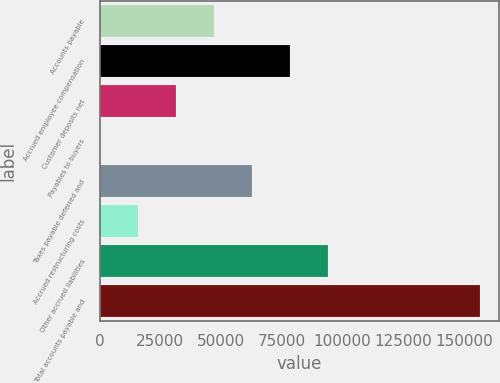Convert chart to OTSL. <chart><loc_0><loc_0><loc_500><loc_500><bar_chart><fcel>Accounts payable<fcel>Accrued employee compensation<fcel>Customer deposits net<fcel>Payables to buyers<fcel>Taxes payable deferred and<fcel>Accrued restructuring costs<fcel>Other accrued liabilities<fcel>Total accounts payable and<nl><fcel>47076.5<fcel>78307.5<fcel>31461<fcel>230<fcel>62692<fcel>15845.5<fcel>93923<fcel>156385<nl></chart> 